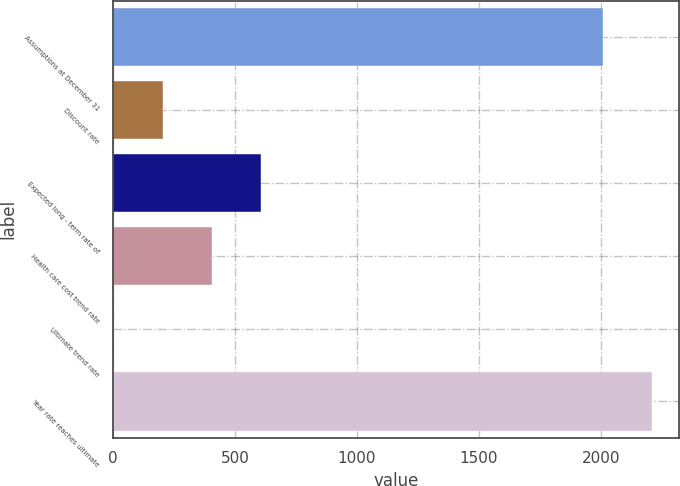Convert chart to OTSL. <chart><loc_0><loc_0><loc_500><loc_500><bar_chart><fcel>Assumptions at December 31<fcel>Discount rate<fcel>Expected long - term rate of<fcel>Health care cost trend rate<fcel>Ultimate trend rate<fcel>Year rate reaches ultimate<nl><fcel>2009<fcel>205.78<fcel>607.84<fcel>406.81<fcel>4.75<fcel>2210.03<nl></chart> 